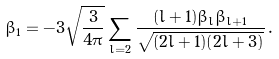Convert formula to latex. <formula><loc_0><loc_0><loc_500><loc_500>\beta _ { 1 } = - 3 \sqrt { \frac { 3 } { 4 \pi } } \sum _ { l = 2 } \frac { ( l + 1 ) \beta _ { l } \beta _ { l + 1 } } { \sqrt { ( 2 l + 1 ) ( 2 l + 3 ) } } \, .</formula> 